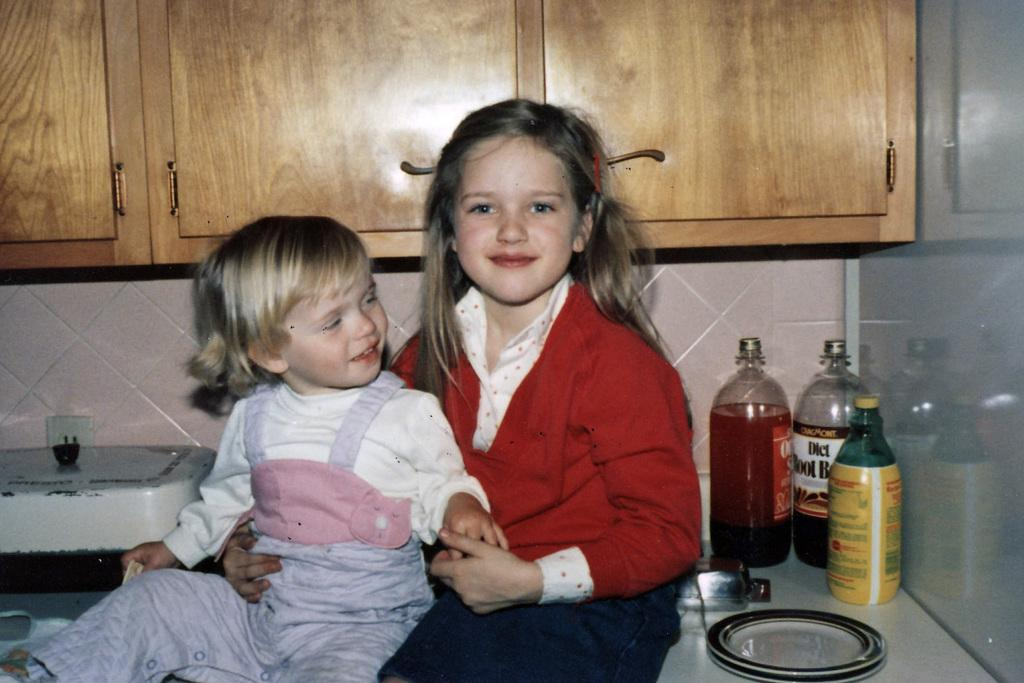<image>
Create a compact narrative representing the image presented. Two girls sit on a counter next to a bottle of diet root beer. 